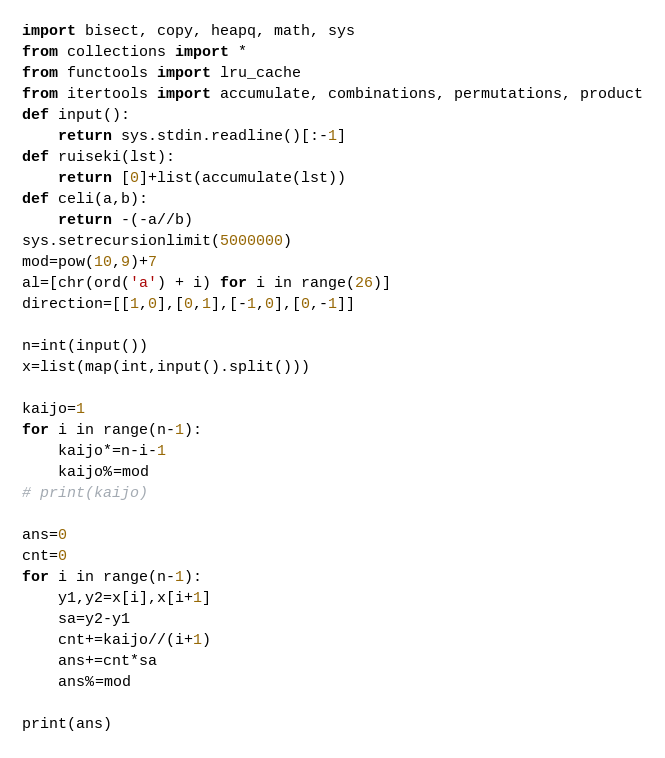<code> <loc_0><loc_0><loc_500><loc_500><_Python_>import bisect, copy, heapq, math, sys
from collections import *
from functools import lru_cache
from itertools import accumulate, combinations, permutations, product
def input():
    return sys.stdin.readline()[:-1]
def ruiseki(lst):
    return [0]+list(accumulate(lst))
def celi(a,b):
    return -(-a//b)
sys.setrecursionlimit(5000000)
mod=pow(10,9)+7
al=[chr(ord('a') + i) for i in range(26)]
direction=[[1,0],[0,1],[-1,0],[0,-1]]

n=int(input())
x=list(map(int,input().split()))

kaijo=1
for i in range(n-1):
    kaijo*=n-i-1
    kaijo%=mod
# print(kaijo)

ans=0
cnt=0
for i in range(n-1):
    y1,y2=x[i],x[i+1]
    sa=y2-y1
    cnt+=kaijo//(i+1)
    ans+=cnt*sa
    ans%=mod

print(ans)</code> 